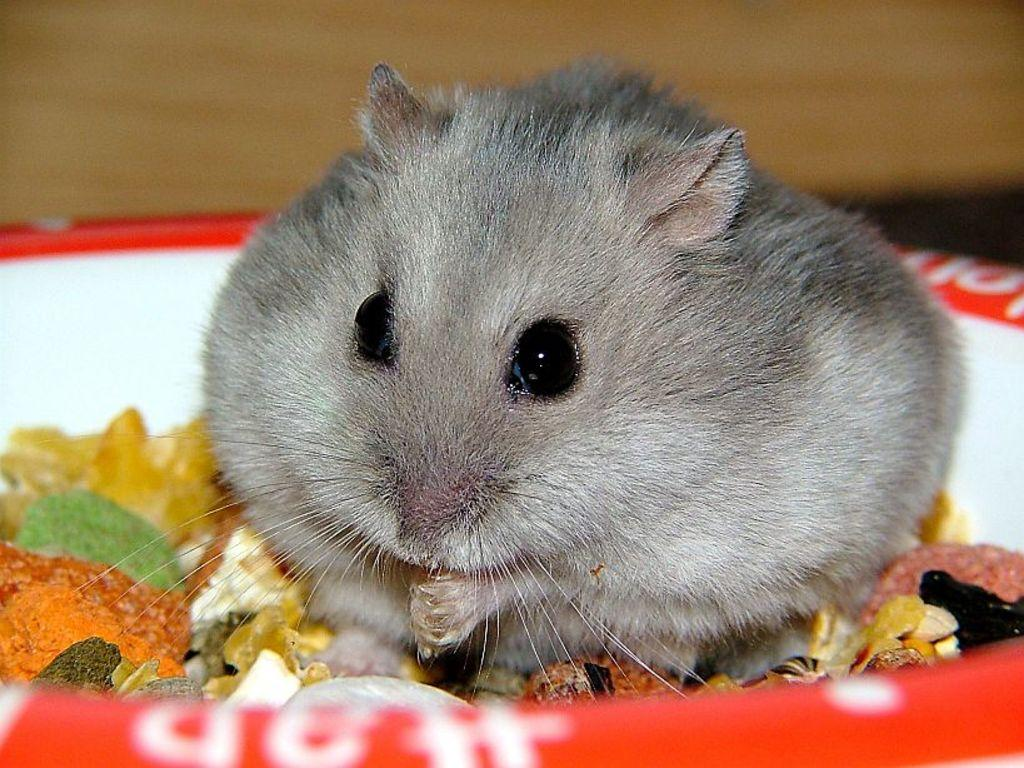What is the main subject in the foreground of the picture? There is a rat in the foreground of the picture. Where is the rat located? The rat is in a bowl. What is in the bowl with the rat? The bowl contains food. What can be seen in the background of the picture? There is a wall in the background of the picture. What type of secretary can be seen working in the background of the image? There is no secretary present in the image; it features a rat in a bowl with food. Is the sand visible in the image? There is no sand visible in the image; it features a rat in a bowl with food and a wall in the background. 